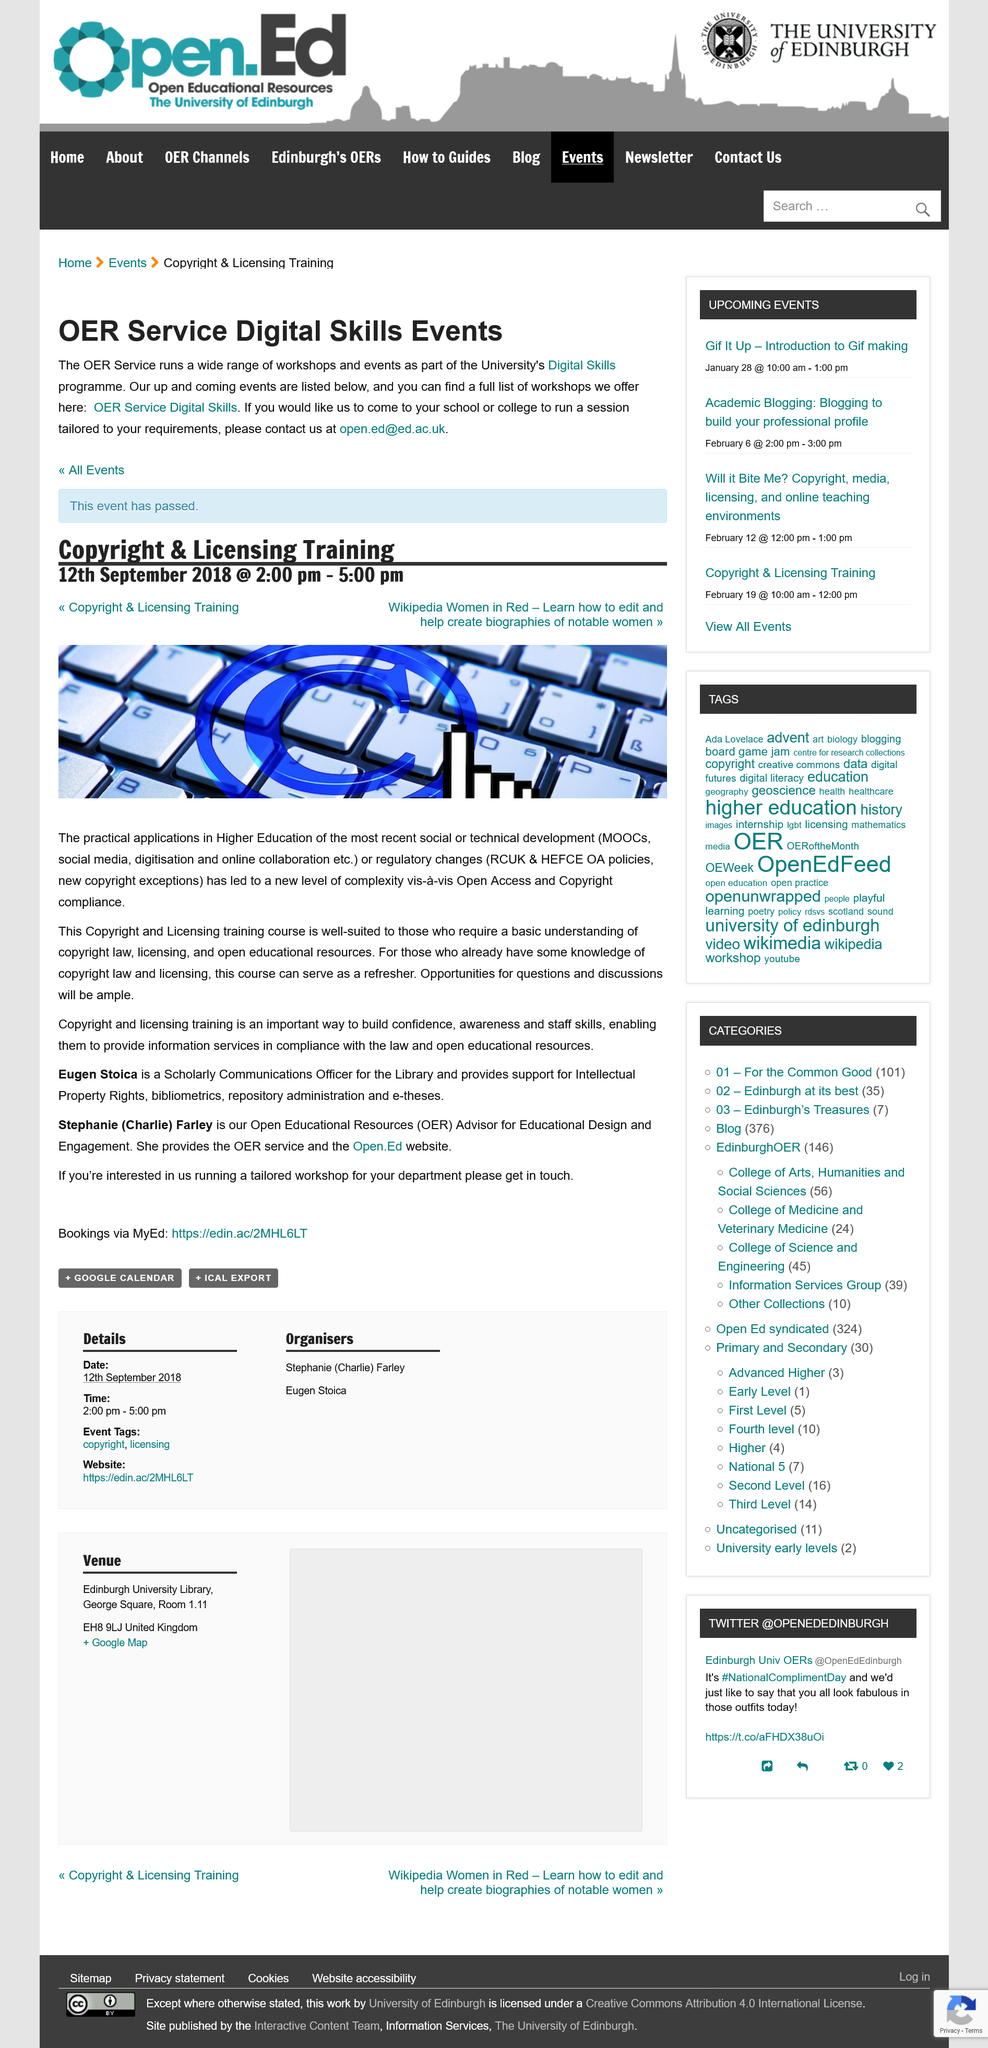Point out several critical features in this image. Eugen Stoica is a Scholarly Communications Officer. The Copyright & licensing Training is being held on Wednesday, September 12th, 2018. Eugen Stoica and Stephanie (Charlie) Farley are instructors of a course on copyright and licensing training. If you want to schedule a session at your school or college, you can contact the Open Education team by emailing [open.ed@ed.ac.uk](mailto:open.ed@ed.ac.uk). Copyright and licensing training is crucial for building confidence, awareness, and staff skills, and ensuring compliance with the law and access to open educational resources for information services. 